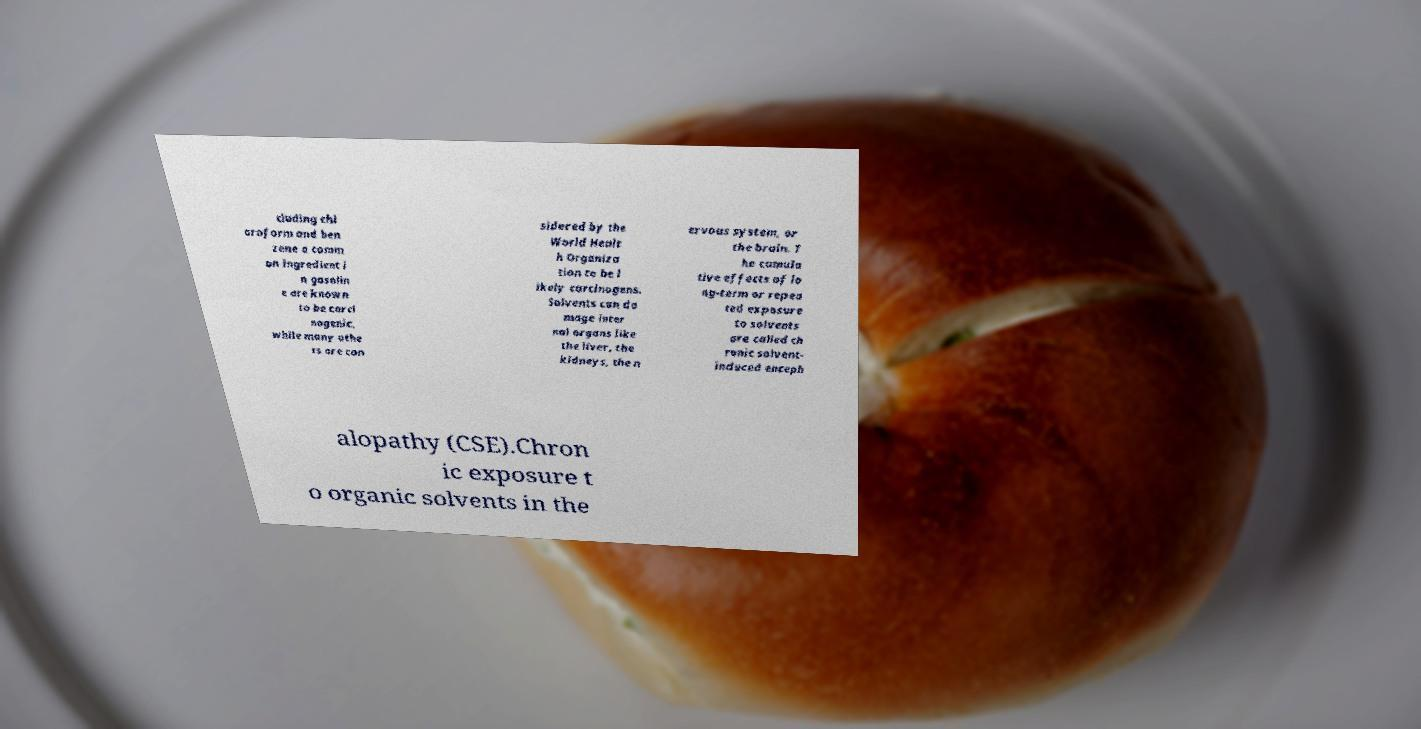Can you read and provide the text displayed in the image?This photo seems to have some interesting text. Can you extract and type it out for me? cluding chl oroform and ben zene a comm on ingredient i n gasolin e are known to be carci nogenic, while many othe rs are con sidered by the World Healt h Organiza tion to be l ikely carcinogens. Solvents can da mage inter nal organs like the liver, the kidneys, the n ervous system, or the brain. T he cumula tive effects of lo ng-term or repea ted exposure to solvents are called ch ronic solvent- induced enceph alopathy (CSE).Chron ic exposure t o organic solvents in the 